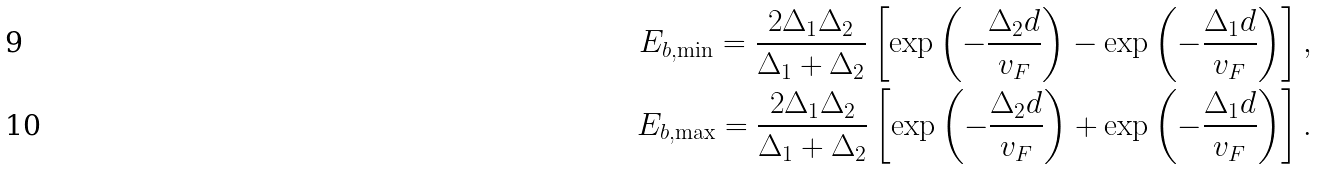<formula> <loc_0><loc_0><loc_500><loc_500>E _ { b , \min } = \frac { 2 \Delta _ { 1 } \Delta _ { 2 } } { \Delta _ { 1 } + \Delta _ { 2 } } \left [ \exp \left ( - \frac { \Delta _ { 2 } d } { v _ { F } } \right ) - \exp \left ( - \frac { \Delta _ { 1 } d } { v _ { F } } \right ) \right ] , \\ E _ { b , \max } = \frac { 2 \Delta _ { 1 } \Delta _ { 2 } } { \Delta _ { 1 } + \Delta _ { 2 } } \left [ \exp \left ( - \frac { \Delta _ { 2 } d } { v _ { F } } \right ) + \exp \left ( - \frac { \Delta _ { 1 } d } { v _ { F } } \right ) \right ] .</formula> 